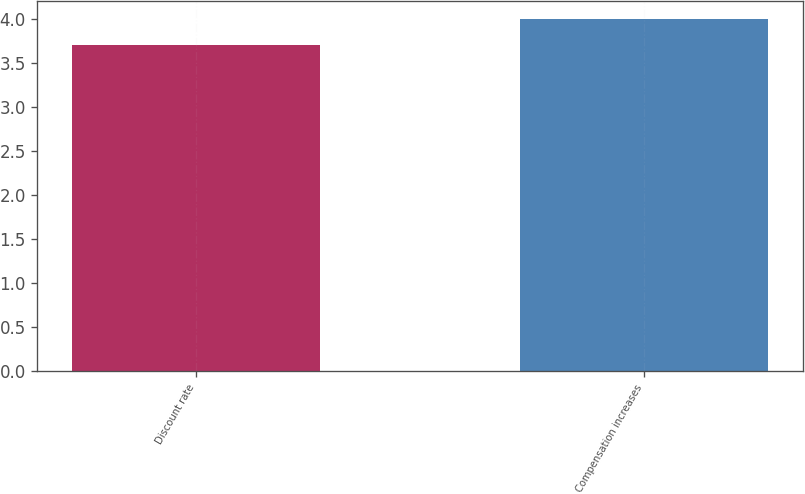Convert chart to OTSL. <chart><loc_0><loc_0><loc_500><loc_500><bar_chart><fcel>Discount rate<fcel>Compensation increases<nl><fcel>3.7<fcel>4<nl></chart> 